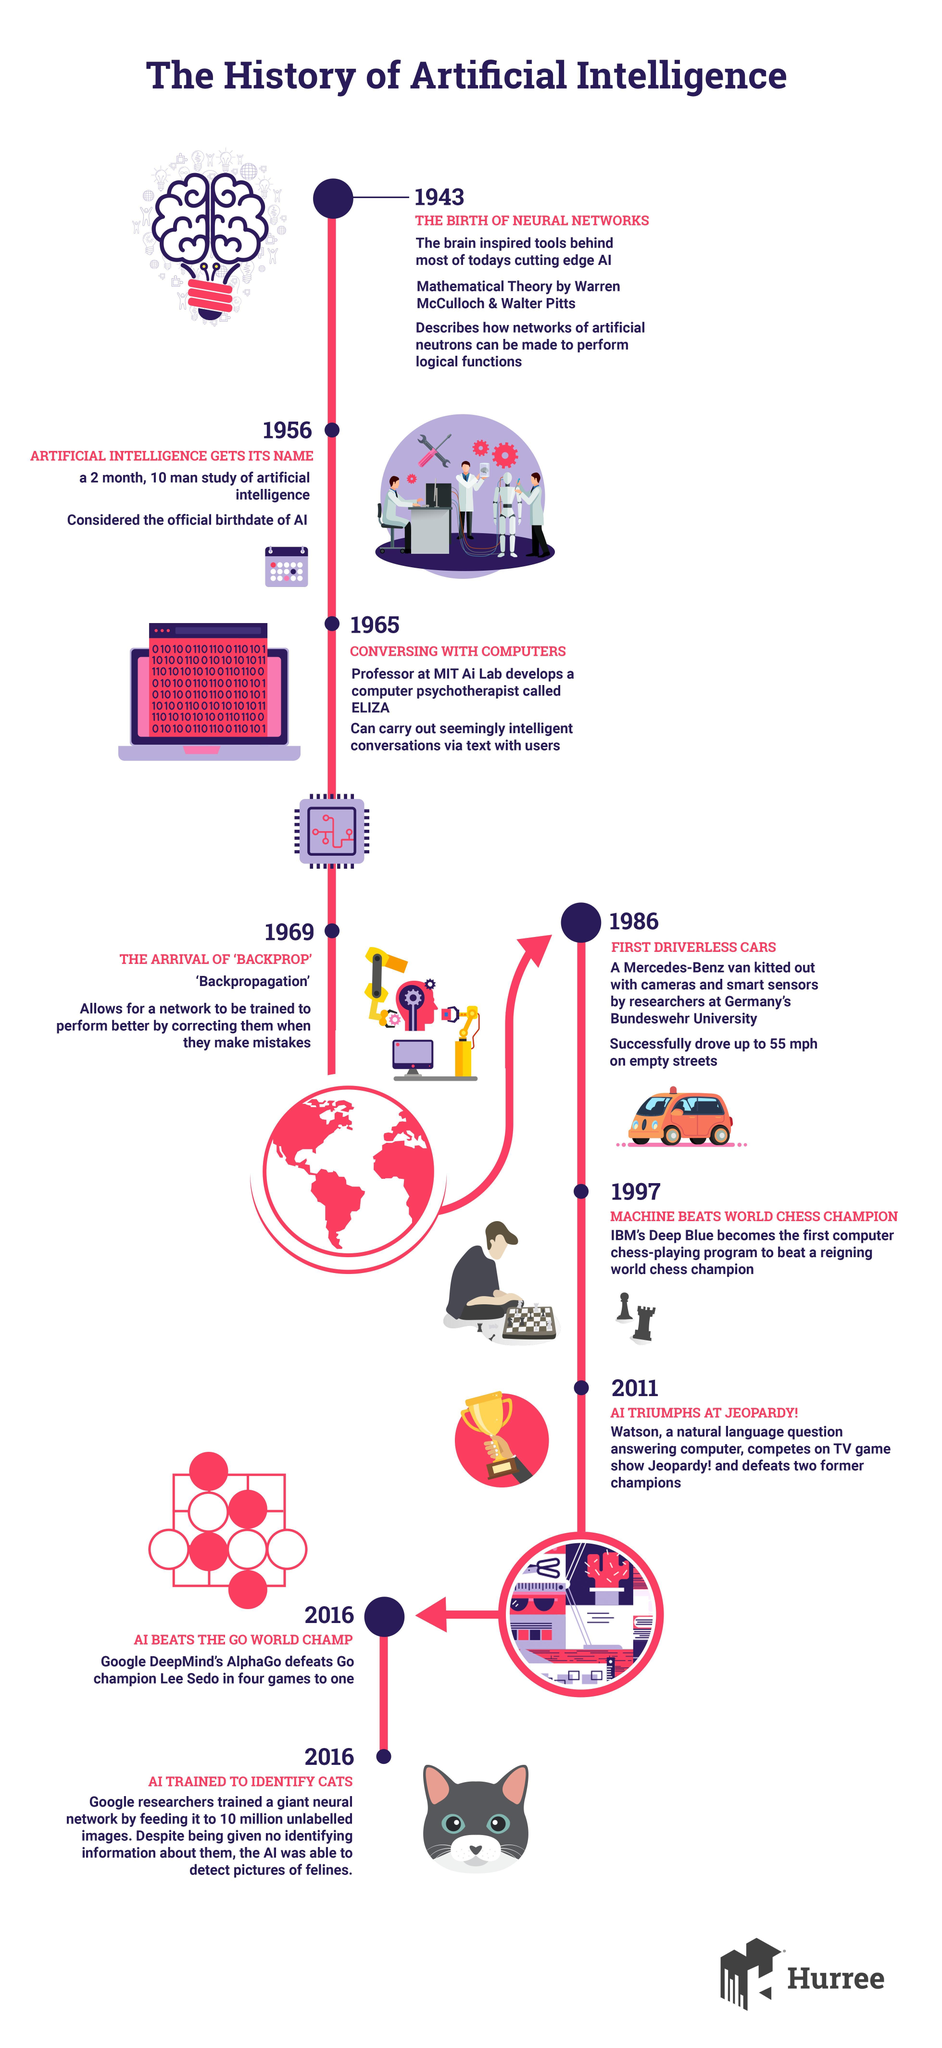what is the colour of the van, orange or yellow
Answer the question with a short phrase. orange what is the game which has soldier and king chess victory at which game does the trophy indicate jepoardy How many years after the birth of neural networks did artificial intelligence get its name 13 which member of the feline family has been mentioned in the report cat Who introduced first driverless cars mercedes benz what allows for a network to be trained to perform better by correcting them when they make mistakes backpropagation 